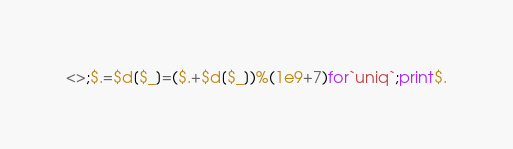<code> <loc_0><loc_0><loc_500><loc_500><_Perl_><>;$.=$d[$_]=($.+$d[$_])%(1e9+7)for`uniq`;print$.</code> 